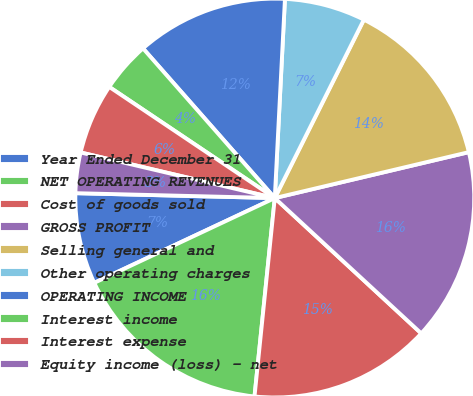Convert chart to OTSL. <chart><loc_0><loc_0><loc_500><loc_500><pie_chart><fcel>Year Ended December 31<fcel>NET OPERATING REVENUES<fcel>Cost of goods sold<fcel>GROSS PROFIT<fcel>Selling general and<fcel>Other operating charges<fcel>OPERATING INCOME<fcel>Interest income<fcel>Interest expense<fcel>Equity income (loss) - net<nl><fcel>7.38%<fcel>16.39%<fcel>14.75%<fcel>15.57%<fcel>13.93%<fcel>6.56%<fcel>12.3%<fcel>4.1%<fcel>5.74%<fcel>3.28%<nl></chart> 